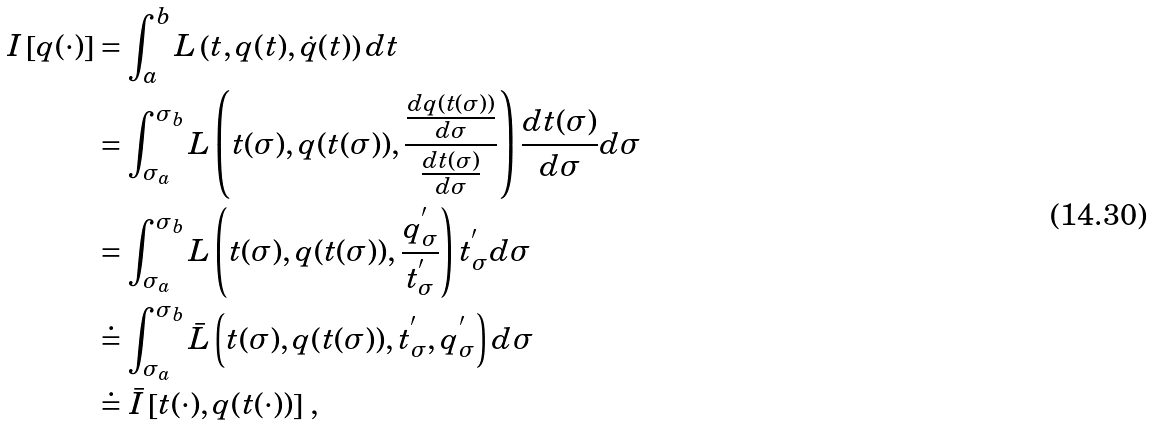<formula> <loc_0><loc_0><loc_500><loc_500>I \left [ q ( \cdot ) \right ] & = \int _ { a } ^ { b } L \left ( t , q ( t ) , \dot { q } ( t ) \right ) d t \\ & = \int _ { \sigma _ { a } } ^ { \sigma _ { b } } L \left ( t ( \sigma ) , q ( t ( \sigma ) ) , \frac { \frac { d q ( t ( \sigma ) ) } { d \sigma } } { \frac { d t ( \sigma ) } { d \sigma } } \right ) \frac { d t ( \sigma ) } { d \sigma } d \sigma \\ & = \int _ { \sigma _ { a } } ^ { \sigma _ { b } } L \left ( t ( \sigma ) , q ( t ( \sigma ) ) , \frac { q _ { \sigma } ^ { ^ { \prime } } } { t _ { \sigma } ^ { ^ { \prime } } } \right ) t _ { \sigma } ^ { ^ { \prime } } d \sigma \\ & \doteq \int _ { \sigma _ { a } } ^ { \sigma _ { b } } \bar { L } \left ( t ( \sigma ) , q ( t ( \sigma ) ) , t _ { \sigma } ^ { ^ { \prime } } , q _ { \sigma } ^ { ^ { \prime } } \right ) d \sigma \\ & \doteq \bar { I } \left [ t ( \cdot ) , q ( t ( \cdot ) ) \right ] \, ,</formula> 